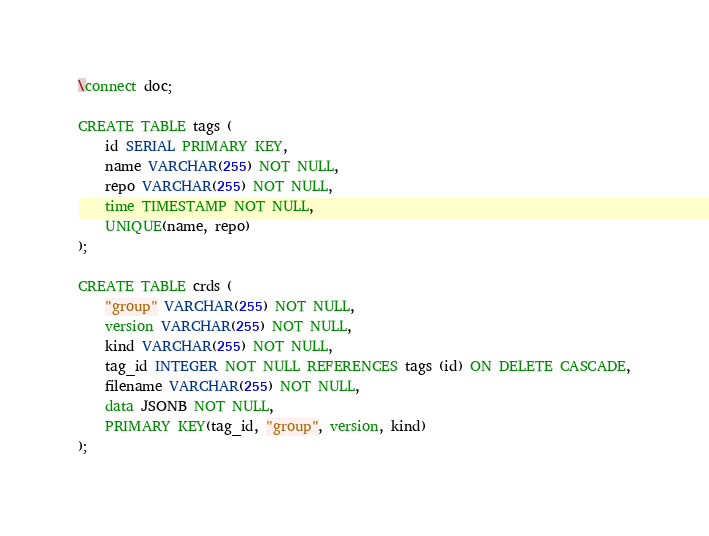<code> <loc_0><loc_0><loc_500><loc_500><_SQL_>
\connect doc;

CREATE TABLE tags (
    id SERIAL PRIMARY KEY,
    name VARCHAR(255) NOT NULL,
    repo VARCHAR(255) NOT NULL,
    time TIMESTAMP NOT NULL,
    UNIQUE(name, repo)
);

CREATE TABLE crds (
    "group" VARCHAR(255) NOT NULL,
    version VARCHAR(255) NOT NULL,
    kind VARCHAR(255) NOT NULL,
    tag_id INTEGER NOT NULL REFERENCES tags (id) ON DELETE CASCADE,
    filename VARCHAR(255) NOT NULL,
    data JSONB NOT NULL,
    PRIMARY KEY(tag_id, "group", version, kind)
);
</code> 